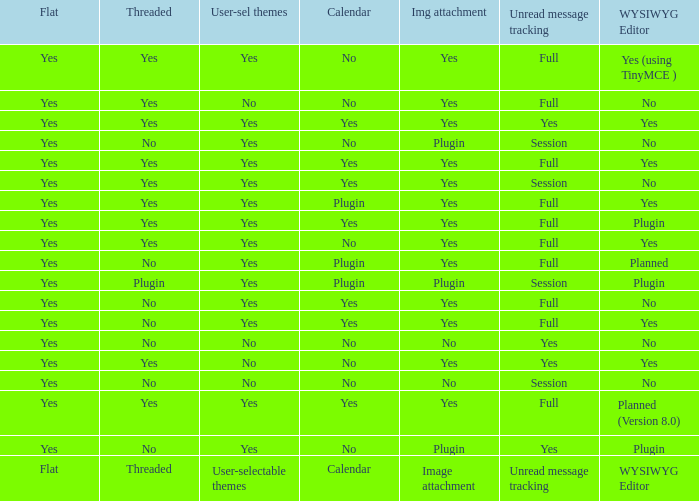Which WYSIWYG Editor has an Image attachment of yes, and a Calendar of plugin? Yes, Planned. 